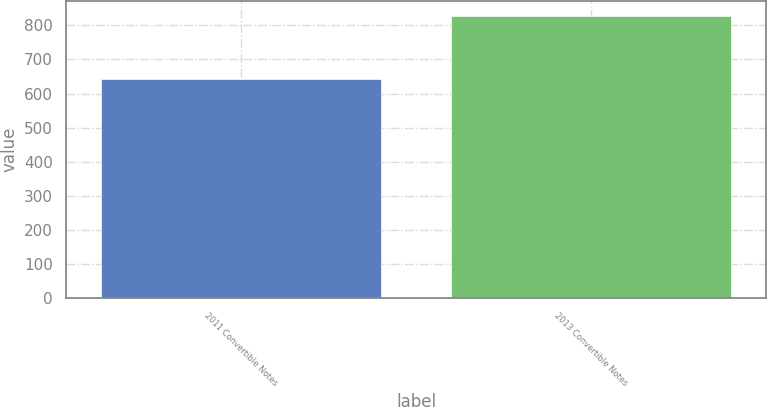Convert chart. <chart><loc_0><loc_0><loc_500><loc_500><bar_chart><fcel>2011 Convertible Notes<fcel>2013 Convertible Notes<nl><fcel>643<fcel>829<nl></chart> 